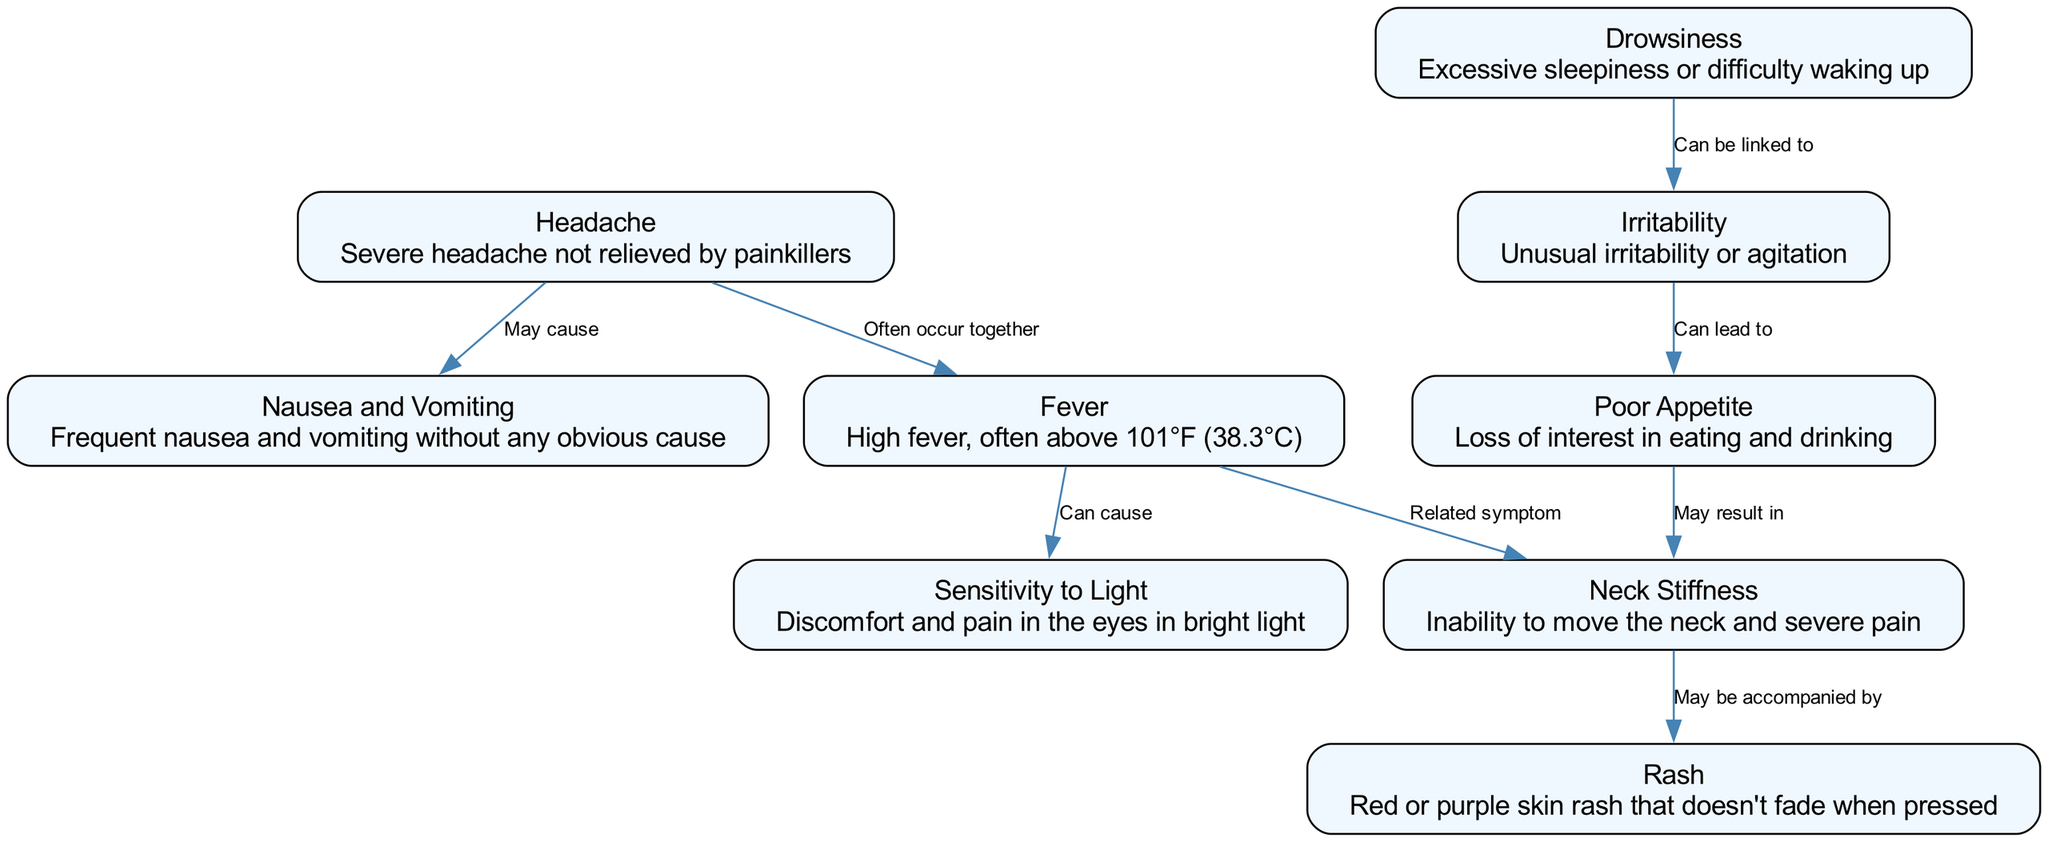What is one of the symptoms listed for meningitis in children? The diagram lists several symptoms associated with meningitis. One of them is "Headache," which is described as a severe headache not relieved by painkillers.
Answer: Headache How high is the fever typically associated with meningitis? According to the diagram, the fever is described as high, often above 101°F (38.3°C).
Answer: Above 101°F What is the relationship between headache and nausea? The diagram shows that headache may cause nausea and vomiting as indicated by the edge labeled "May cause" connecting headache to nausea and vomiting.
Answer: May cause How many nodes are there in total representing symptoms? By counting the nodes presented in the diagram, there are nine nodes that depict different symptoms associated with meningitis.
Answer: Nine What symptom is specifically linked to drowsiness? The diagram indicates that excessive sleepiness or difficulty waking up (drowsiness) can be linked to unusual irritability or agitation, as shown by the edge labeled "Can be linked to."
Answer: Unusual irritability Which symptom is associated with neck stiffness? The diagram mentions that neck stiffness may be accompanied by a rash, represented by the edge that indicates the relationship "May be accompanied by."
Answer: Rash What symptoms often occur together with fever? The diagram suggests that headache often occurs together with fever, indicated by the edge labeled "Often occur together" connecting headache to fever.
Answer: Headache What color is the rash described in the diagram? The diagram specifies that the rash associated with meningitis is red or purple, so the answer can be found in the description of the rash node.
Answer: Red or purple What can a poor appetite lead to according to the diagram? The diagram indicates that poor appetite may result in neck stiffness as shown by the directional edge labeled "May result in."
Answer: Neck stiffness 